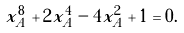<formula> <loc_0><loc_0><loc_500><loc_500>x _ { A } ^ { 8 } + 2 x _ { A } ^ { 4 } - 4 x _ { A } ^ { 2 } + 1 = 0 .</formula> 